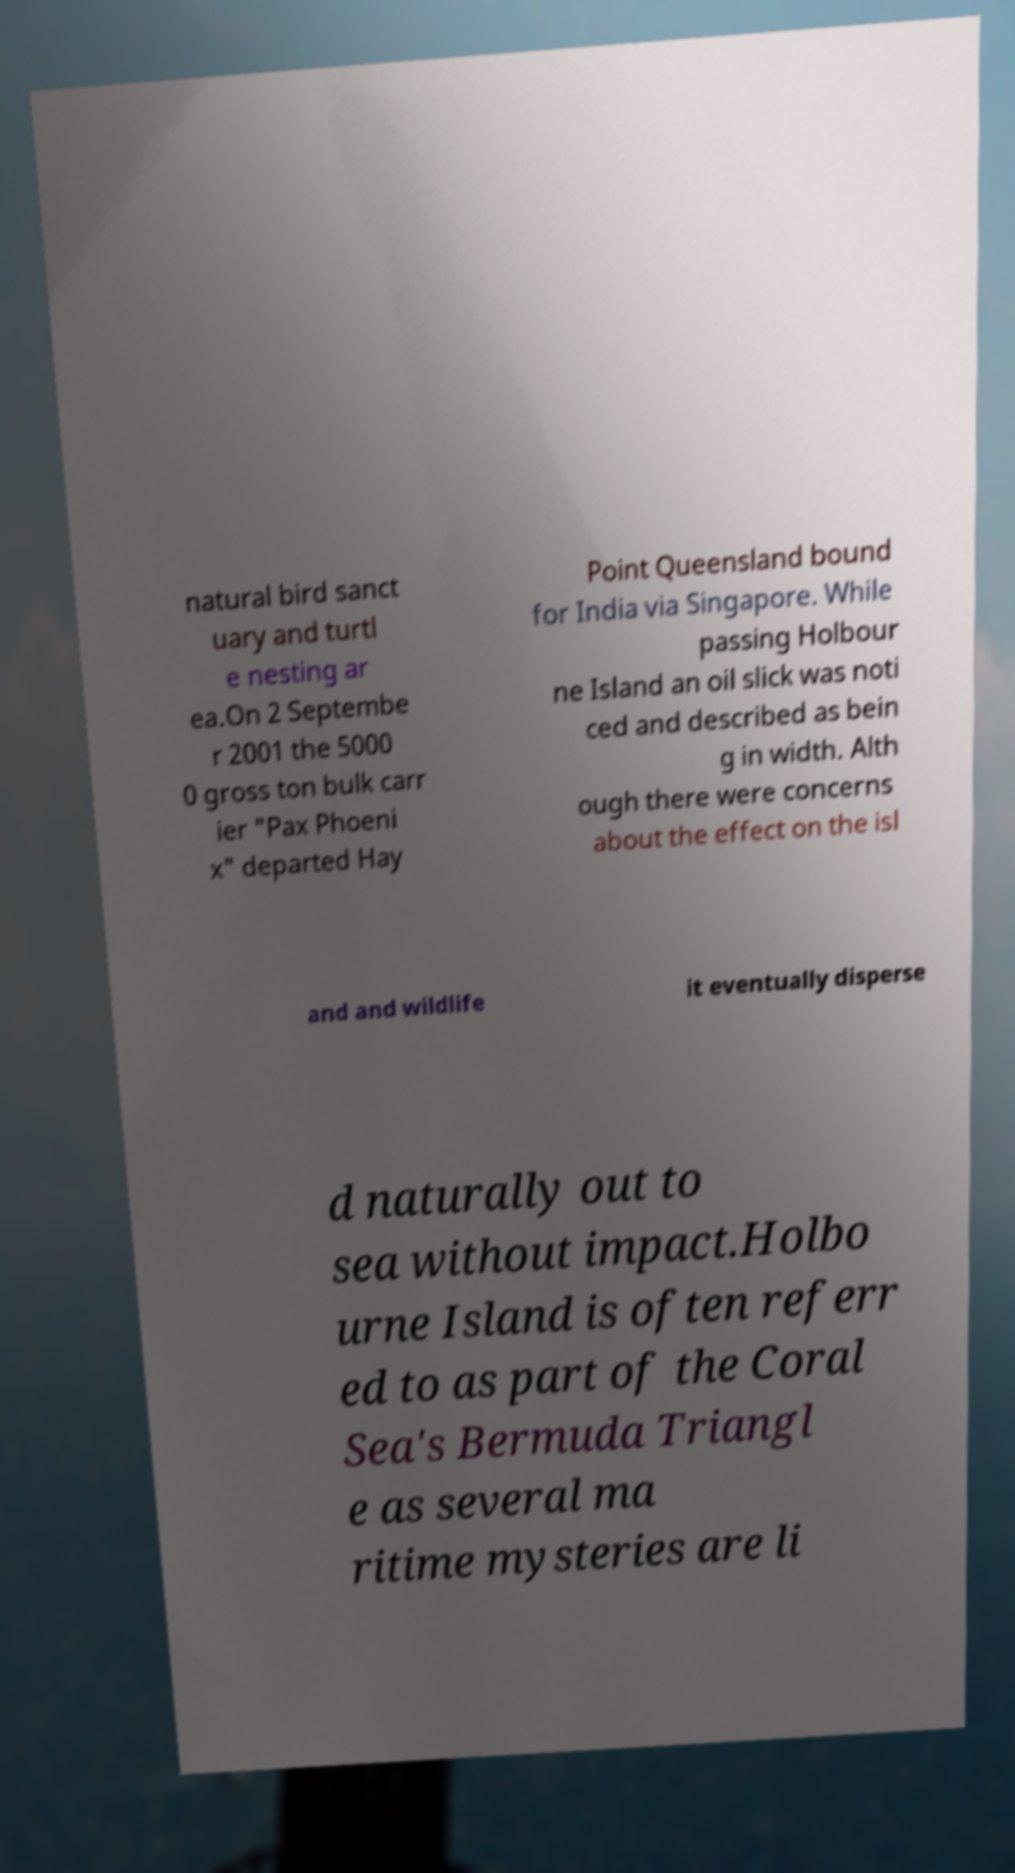What messages or text are displayed in this image? I need them in a readable, typed format. natural bird sanct uary and turtl e nesting ar ea.On 2 Septembe r 2001 the 5000 0 gross ton bulk carr ier "Pax Phoeni x" departed Hay Point Queensland bound for India via Singapore. While passing Holbour ne Island an oil slick was noti ced and described as bein g in width. Alth ough there were concerns about the effect on the isl and and wildlife it eventually disperse d naturally out to sea without impact.Holbo urne Island is often referr ed to as part of the Coral Sea's Bermuda Triangl e as several ma ritime mysteries are li 